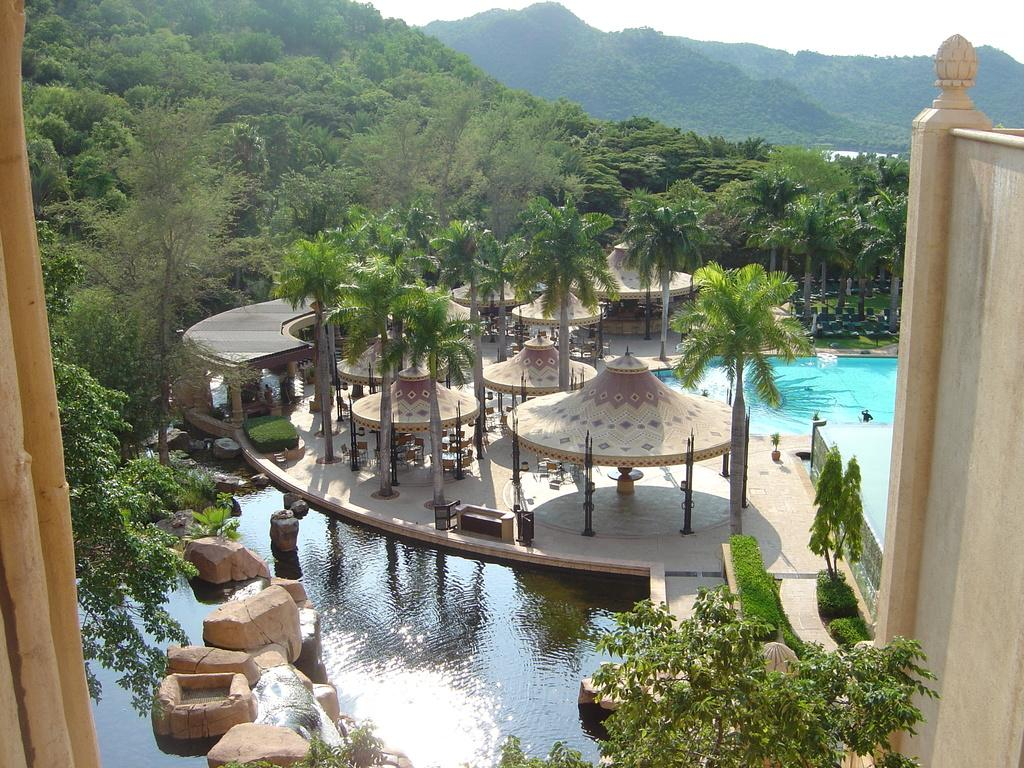What type of natural elements can be seen in the image? There are trees and rocks visible in the image. What is the water feature in the image? There is water visible in the image. What type of structure can be seen in the image? There is a garden shelter in the image. What can be seen in the distance in the image? In the background of the image, there are hills. What story is being told by the sock in the image? There is no sock present in the image, so no story can be told by it. 